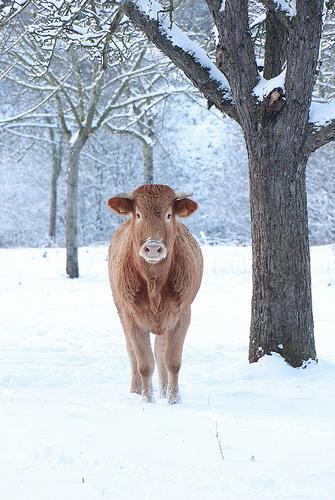How many cows are there?
Give a very brief answer. 1. 